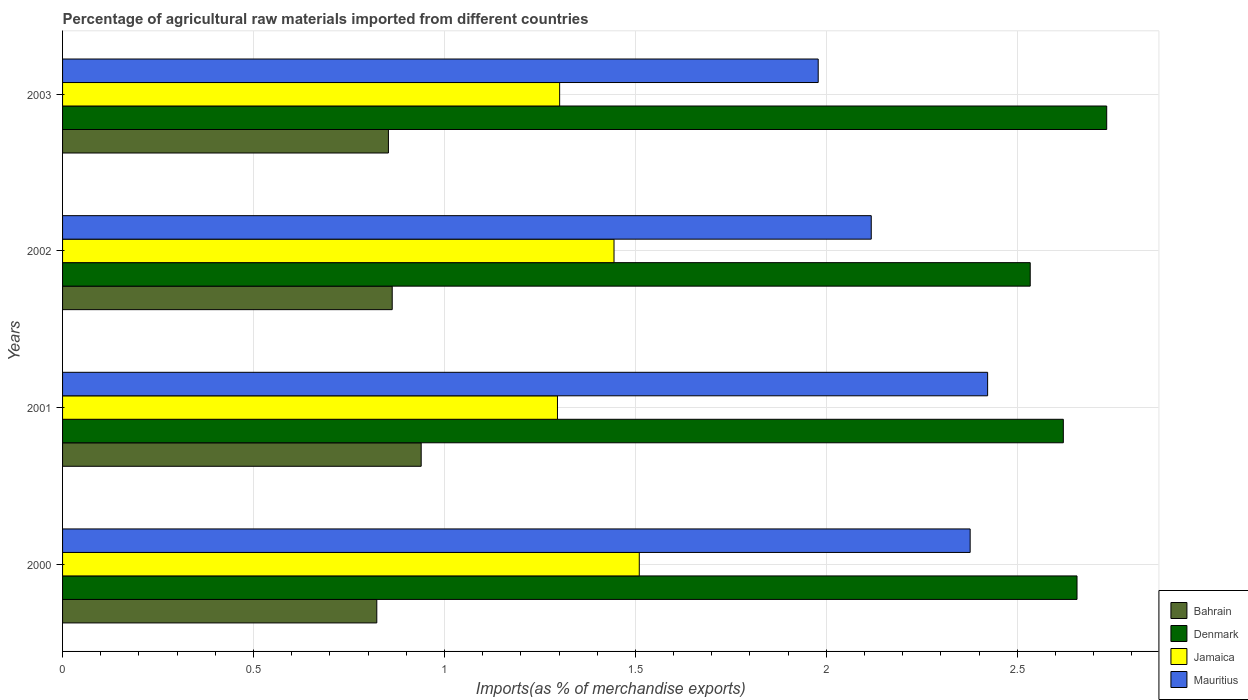How many different coloured bars are there?
Offer a terse response. 4. How many groups of bars are there?
Keep it short and to the point. 4. Are the number of bars per tick equal to the number of legend labels?
Your answer should be very brief. Yes. How many bars are there on the 2nd tick from the bottom?
Provide a succinct answer. 4. What is the label of the 2nd group of bars from the top?
Offer a very short reply. 2002. In how many cases, is the number of bars for a given year not equal to the number of legend labels?
Give a very brief answer. 0. What is the percentage of imports to different countries in Jamaica in 2002?
Keep it short and to the point. 1.44. Across all years, what is the maximum percentage of imports to different countries in Denmark?
Ensure brevity in your answer.  2.73. Across all years, what is the minimum percentage of imports to different countries in Mauritius?
Provide a short and direct response. 1.98. In which year was the percentage of imports to different countries in Denmark maximum?
Ensure brevity in your answer.  2003. What is the total percentage of imports to different countries in Denmark in the graph?
Keep it short and to the point. 10.55. What is the difference between the percentage of imports to different countries in Bahrain in 2002 and that in 2003?
Make the answer very short. 0.01. What is the difference between the percentage of imports to different countries in Jamaica in 2001 and the percentage of imports to different countries in Bahrain in 2002?
Your answer should be very brief. 0.43. What is the average percentage of imports to different countries in Mauritius per year?
Keep it short and to the point. 2.22. In the year 2002, what is the difference between the percentage of imports to different countries in Denmark and percentage of imports to different countries in Mauritius?
Your response must be concise. 0.42. What is the ratio of the percentage of imports to different countries in Jamaica in 2001 to that in 2002?
Your response must be concise. 0.9. Is the percentage of imports to different countries in Denmark in 2001 less than that in 2002?
Ensure brevity in your answer.  No. Is the difference between the percentage of imports to different countries in Denmark in 2001 and 2003 greater than the difference between the percentage of imports to different countries in Mauritius in 2001 and 2003?
Offer a very short reply. No. What is the difference between the highest and the second highest percentage of imports to different countries in Bahrain?
Offer a terse response. 0.08. What is the difference between the highest and the lowest percentage of imports to different countries in Mauritius?
Make the answer very short. 0.44. Is it the case that in every year, the sum of the percentage of imports to different countries in Mauritius and percentage of imports to different countries in Bahrain is greater than the sum of percentage of imports to different countries in Jamaica and percentage of imports to different countries in Denmark?
Provide a succinct answer. No. What does the 2nd bar from the top in 2000 represents?
Provide a short and direct response. Jamaica. What does the 3rd bar from the bottom in 2001 represents?
Provide a succinct answer. Jamaica. Is it the case that in every year, the sum of the percentage of imports to different countries in Mauritius and percentage of imports to different countries in Denmark is greater than the percentage of imports to different countries in Bahrain?
Give a very brief answer. Yes. How many bars are there?
Your answer should be very brief. 16. Are all the bars in the graph horizontal?
Make the answer very short. Yes. Are the values on the major ticks of X-axis written in scientific E-notation?
Offer a very short reply. No. Does the graph contain any zero values?
Offer a very short reply. No. What is the title of the graph?
Your answer should be compact. Percentage of agricultural raw materials imported from different countries. What is the label or title of the X-axis?
Your answer should be compact. Imports(as % of merchandise exports). What is the label or title of the Y-axis?
Offer a very short reply. Years. What is the Imports(as % of merchandise exports) in Bahrain in 2000?
Keep it short and to the point. 0.82. What is the Imports(as % of merchandise exports) in Denmark in 2000?
Keep it short and to the point. 2.66. What is the Imports(as % of merchandise exports) in Jamaica in 2000?
Your answer should be compact. 1.51. What is the Imports(as % of merchandise exports) in Mauritius in 2000?
Offer a very short reply. 2.38. What is the Imports(as % of merchandise exports) of Bahrain in 2001?
Keep it short and to the point. 0.94. What is the Imports(as % of merchandise exports) of Denmark in 2001?
Keep it short and to the point. 2.62. What is the Imports(as % of merchandise exports) in Jamaica in 2001?
Provide a short and direct response. 1.3. What is the Imports(as % of merchandise exports) in Mauritius in 2001?
Ensure brevity in your answer.  2.42. What is the Imports(as % of merchandise exports) in Bahrain in 2002?
Keep it short and to the point. 0.86. What is the Imports(as % of merchandise exports) in Denmark in 2002?
Ensure brevity in your answer.  2.53. What is the Imports(as % of merchandise exports) in Jamaica in 2002?
Provide a succinct answer. 1.44. What is the Imports(as % of merchandise exports) in Mauritius in 2002?
Your answer should be compact. 2.12. What is the Imports(as % of merchandise exports) of Bahrain in 2003?
Give a very brief answer. 0.85. What is the Imports(as % of merchandise exports) of Denmark in 2003?
Offer a terse response. 2.73. What is the Imports(as % of merchandise exports) in Jamaica in 2003?
Offer a terse response. 1.3. What is the Imports(as % of merchandise exports) of Mauritius in 2003?
Offer a terse response. 1.98. Across all years, what is the maximum Imports(as % of merchandise exports) in Bahrain?
Provide a succinct answer. 0.94. Across all years, what is the maximum Imports(as % of merchandise exports) in Denmark?
Offer a very short reply. 2.73. Across all years, what is the maximum Imports(as % of merchandise exports) in Jamaica?
Keep it short and to the point. 1.51. Across all years, what is the maximum Imports(as % of merchandise exports) in Mauritius?
Offer a terse response. 2.42. Across all years, what is the minimum Imports(as % of merchandise exports) of Bahrain?
Provide a succinct answer. 0.82. Across all years, what is the minimum Imports(as % of merchandise exports) in Denmark?
Provide a succinct answer. 2.53. Across all years, what is the minimum Imports(as % of merchandise exports) in Jamaica?
Provide a short and direct response. 1.3. Across all years, what is the minimum Imports(as % of merchandise exports) in Mauritius?
Give a very brief answer. 1.98. What is the total Imports(as % of merchandise exports) of Bahrain in the graph?
Provide a short and direct response. 3.48. What is the total Imports(as % of merchandise exports) in Denmark in the graph?
Offer a very short reply. 10.55. What is the total Imports(as % of merchandise exports) in Jamaica in the graph?
Keep it short and to the point. 5.55. What is the total Imports(as % of merchandise exports) in Mauritius in the graph?
Ensure brevity in your answer.  8.9. What is the difference between the Imports(as % of merchandise exports) of Bahrain in 2000 and that in 2001?
Give a very brief answer. -0.12. What is the difference between the Imports(as % of merchandise exports) in Denmark in 2000 and that in 2001?
Your response must be concise. 0.04. What is the difference between the Imports(as % of merchandise exports) in Jamaica in 2000 and that in 2001?
Your response must be concise. 0.21. What is the difference between the Imports(as % of merchandise exports) of Mauritius in 2000 and that in 2001?
Ensure brevity in your answer.  -0.05. What is the difference between the Imports(as % of merchandise exports) of Bahrain in 2000 and that in 2002?
Provide a short and direct response. -0.04. What is the difference between the Imports(as % of merchandise exports) in Denmark in 2000 and that in 2002?
Offer a very short reply. 0.12. What is the difference between the Imports(as % of merchandise exports) in Jamaica in 2000 and that in 2002?
Make the answer very short. 0.07. What is the difference between the Imports(as % of merchandise exports) in Mauritius in 2000 and that in 2002?
Your response must be concise. 0.26. What is the difference between the Imports(as % of merchandise exports) of Bahrain in 2000 and that in 2003?
Your answer should be very brief. -0.03. What is the difference between the Imports(as % of merchandise exports) of Denmark in 2000 and that in 2003?
Provide a succinct answer. -0.08. What is the difference between the Imports(as % of merchandise exports) in Jamaica in 2000 and that in 2003?
Give a very brief answer. 0.21. What is the difference between the Imports(as % of merchandise exports) in Mauritius in 2000 and that in 2003?
Give a very brief answer. 0.4. What is the difference between the Imports(as % of merchandise exports) in Bahrain in 2001 and that in 2002?
Make the answer very short. 0.08. What is the difference between the Imports(as % of merchandise exports) of Denmark in 2001 and that in 2002?
Your answer should be compact. 0.09. What is the difference between the Imports(as % of merchandise exports) in Jamaica in 2001 and that in 2002?
Provide a succinct answer. -0.15. What is the difference between the Imports(as % of merchandise exports) of Mauritius in 2001 and that in 2002?
Your answer should be compact. 0.3. What is the difference between the Imports(as % of merchandise exports) in Bahrain in 2001 and that in 2003?
Your answer should be compact. 0.09. What is the difference between the Imports(as % of merchandise exports) of Denmark in 2001 and that in 2003?
Your response must be concise. -0.11. What is the difference between the Imports(as % of merchandise exports) of Jamaica in 2001 and that in 2003?
Provide a short and direct response. -0.01. What is the difference between the Imports(as % of merchandise exports) in Mauritius in 2001 and that in 2003?
Your answer should be very brief. 0.44. What is the difference between the Imports(as % of merchandise exports) in Bahrain in 2002 and that in 2003?
Your answer should be compact. 0.01. What is the difference between the Imports(as % of merchandise exports) of Denmark in 2002 and that in 2003?
Provide a succinct answer. -0.2. What is the difference between the Imports(as % of merchandise exports) in Jamaica in 2002 and that in 2003?
Offer a very short reply. 0.14. What is the difference between the Imports(as % of merchandise exports) in Mauritius in 2002 and that in 2003?
Offer a very short reply. 0.14. What is the difference between the Imports(as % of merchandise exports) in Bahrain in 2000 and the Imports(as % of merchandise exports) in Denmark in 2001?
Your answer should be compact. -1.8. What is the difference between the Imports(as % of merchandise exports) in Bahrain in 2000 and the Imports(as % of merchandise exports) in Jamaica in 2001?
Your answer should be very brief. -0.47. What is the difference between the Imports(as % of merchandise exports) in Bahrain in 2000 and the Imports(as % of merchandise exports) in Mauritius in 2001?
Your answer should be compact. -1.6. What is the difference between the Imports(as % of merchandise exports) in Denmark in 2000 and the Imports(as % of merchandise exports) in Jamaica in 2001?
Provide a short and direct response. 1.36. What is the difference between the Imports(as % of merchandise exports) in Denmark in 2000 and the Imports(as % of merchandise exports) in Mauritius in 2001?
Ensure brevity in your answer.  0.23. What is the difference between the Imports(as % of merchandise exports) of Jamaica in 2000 and the Imports(as % of merchandise exports) of Mauritius in 2001?
Your answer should be compact. -0.91. What is the difference between the Imports(as % of merchandise exports) of Bahrain in 2000 and the Imports(as % of merchandise exports) of Denmark in 2002?
Keep it short and to the point. -1.71. What is the difference between the Imports(as % of merchandise exports) of Bahrain in 2000 and the Imports(as % of merchandise exports) of Jamaica in 2002?
Your answer should be very brief. -0.62. What is the difference between the Imports(as % of merchandise exports) of Bahrain in 2000 and the Imports(as % of merchandise exports) of Mauritius in 2002?
Your answer should be very brief. -1.29. What is the difference between the Imports(as % of merchandise exports) of Denmark in 2000 and the Imports(as % of merchandise exports) of Jamaica in 2002?
Offer a terse response. 1.21. What is the difference between the Imports(as % of merchandise exports) in Denmark in 2000 and the Imports(as % of merchandise exports) in Mauritius in 2002?
Make the answer very short. 0.54. What is the difference between the Imports(as % of merchandise exports) of Jamaica in 2000 and the Imports(as % of merchandise exports) of Mauritius in 2002?
Offer a very short reply. -0.61. What is the difference between the Imports(as % of merchandise exports) in Bahrain in 2000 and the Imports(as % of merchandise exports) in Denmark in 2003?
Your answer should be very brief. -1.91. What is the difference between the Imports(as % of merchandise exports) in Bahrain in 2000 and the Imports(as % of merchandise exports) in Jamaica in 2003?
Ensure brevity in your answer.  -0.48. What is the difference between the Imports(as % of merchandise exports) of Bahrain in 2000 and the Imports(as % of merchandise exports) of Mauritius in 2003?
Offer a very short reply. -1.16. What is the difference between the Imports(as % of merchandise exports) in Denmark in 2000 and the Imports(as % of merchandise exports) in Jamaica in 2003?
Offer a terse response. 1.35. What is the difference between the Imports(as % of merchandise exports) in Denmark in 2000 and the Imports(as % of merchandise exports) in Mauritius in 2003?
Keep it short and to the point. 0.68. What is the difference between the Imports(as % of merchandise exports) in Jamaica in 2000 and the Imports(as % of merchandise exports) in Mauritius in 2003?
Provide a short and direct response. -0.47. What is the difference between the Imports(as % of merchandise exports) in Bahrain in 2001 and the Imports(as % of merchandise exports) in Denmark in 2002?
Make the answer very short. -1.59. What is the difference between the Imports(as % of merchandise exports) in Bahrain in 2001 and the Imports(as % of merchandise exports) in Jamaica in 2002?
Your response must be concise. -0.51. What is the difference between the Imports(as % of merchandise exports) in Bahrain in 2001 and the Imports(as % of merchandise exports) in Mauritius in 2002?
Offer a terse response. -1.18. What is the difference between the Imports(as % of merchandise exports) of Denmark in 2001 and the Imports(as % of merchandise exports) of Jamaica in 2002?
Ensure brevity in your answer.  1.18. What is the difference between the Imports(as % of merchandise exports) in Denmark in 2001 and the Imports(as % of merchandise exports) in Mauritius in 2002?
Keep it short and to the point. 0.5. What is the difference between the Imports(as % of merchandise exports) of Jamaica in 2001 and the Imports(as % of merchandise exports) of Mauritius in 2002?
Provide a succinct answer. -0.82. What is the difference between the Imports(as % of merchandise exports) in Bahrain in 2001 and the Imports(as % of merchandise exports) in Denmark in 2003?
Keep it short and to the point. -1.8. What is the difference between the Imports(as % of merchandise exports) of Bahrain in 2001 and the Imports(as % of merchandise exports) of Jamaica in 2003?
Your answer should be very brief. -0.36. What is the difference between the Imports(as % of merchandise exports) in Bahrain in 2001 and the Imports(as % of merchandise exports) in Mauritius in 2003?
Provide a succinct answer. -1.04. What is the difference between the Imports(as % of merchandise exports) in Denmark in 2001 and the Imports(as % of merchandise exports) in Jamaica in 2003?
Offer a very short reply. 1.32. What is the difference between the Imports(as % of merchandise exports) in Denmark in 2001 and the Imports(as % of merchandise exports) in Mauritius in 2003?
Your answer should be very brief. 0.64. What is the difference between the Imports(as % of merchandise exports) of Jamaica in 2001 and the Imports(as % of merchandise exports) of Mauritius in 2003?
Offer a very short reply. -0.68. What is the difference between the Imports(as % of merchandise exports) of Bahrain in 2002 and the Imports(as % of merchandise exports) of Denmark in 2003?
Offer a very short reply. -1.87. What is the difference between the Imports(as % of merchandise exports) in Bahrain in 2002 and the Imports(as % of merchandise exports) in Jamaica in 2003?
Your answer should be compact. -0.44. What is the difference between the Imports(as % of merchandise exports) of Bahrain in 2002 and the Imports(as % of merchandise exports) of Mauritius in 2003?
Provide a succinct answer. -1.12. What is the difference between the Imports(as % of merchandise exports) in Denmark in 2002 and the Imports(as % of merchandise exports) in Jamaica in 2003?
Provide a succinct answer. 1.23. What is the difference between the Imports(as % of merchandise exports) in Denmark in 2002 and the Imports(as % of merchandise exports) in Mauritius in 2003?
Offer a very short reply. 0.56. What is the difference between the Imports(as % of merchandise exports) in Jamaica in 2002 and the Imports(as % of merchandise exports) in Mauritius in 2003?
Provide a succinct answer. -0.53. What is the average Imports(as % of merchandise exports) of Bahrain per year?
Your response must be concise. 0.87. What is the average Imports(as % of merchandise exports) in Denmark per year?
Provide a short and direct response. 2.64. What is the average Imports(as % of merchandise exports) in Jamaica per year?
Offer a terse response. 1.39. What is the average Imports(as % of merchandise exports) in Mauritius per year?
Ensure brevity in your answer.  2.22. In the year 2000, what is the difference between the Imports(as % of merchandise exports) in Bahrain and Imports(as % of merchandise exports) in Denmark?
Your answer should be compact. -1.83. In the year 2000, what is the difference between the Imports(as % of merchandise exports) of Bahrain and Imports(as % of merchandise exports) of Jamaica?
Offer a terse response. -0.69. In the year 2000, what is the difference between the Imports(as % of merchandise exports) of Bahrain and Imports(as % of merchandise exports) of Mauritius?
Offer a very short reply. -1.55. In the year 2000, what is the difference between the Imports(as % of merchandise exports) in Denmark and Imports(as % of merchandise exports) in Jamaica?
Make the answer very short. 1.15. In the year 2000, what is the difference between the Imports(as % of merchandise exports) in Denmark and Imports(as % of merchandise exports) in Mauritius?
Your answer should be compact. 0.28. In the year 2000, what is the difference between the Imports(as % of merchandise exports) in Jamaica and Imports(as % of merchandise exports) in Mauritius?
Make the answer very short. -0.87. In the year 2001, what is the difference between the Imports(as % of merchandise exports) of Bahrain and Imports(as % of merchandise exports) of Denmark?
Your answer should be compact. -1.68. In the year 2001, what is the difference between the Imports(as % of merchandise exports) of Bahrain and Imports(as % of merchandise exports) of Jamaica?
Offer a terse response. -0.36. In the year 2001, what is the difference between the Imports(as % of merchandise exports) in Bahrain and Imports(as % of merchandise exports) in Mauritius?
Your answer should be compact. -1.48. In the year 2001, what is the difference between the Imports(as % of merchandise exports) of Denmark and Imports(as % of merchandise exports) of Jamaica?
Ensure brevity in your answer.  1.32. In the year 2001, what is the difference between the Imports(as % of merchandise exports) of Denmark and Imports(as % of merchandise exports) of Mauritius?
Provide a succinct answer. 0.2. In the year 2001, what is the difference between the Imports(as % of merchandise exports) in Jamaica and Imports(as % of merchandise exports) in Mauritius?
Give a very brief answer. -1.13. In the year 2002, what is the difference between the Imports(as % of merchandise exports) of Bahrain and Imports(as % of merchandise exports) of Denmark?
Provide a short and direct response. -1.67. In the year 2002, what is the difference between the Imports(as % of merchandise exports) of Bahrain and Imports(as % of merchandise exports) of Jamaica?
Offer a terse response. -0.58. In the year 2002, what is the difference between the Imports(as % of merchandise exports) in Bahrain and Imports(as % of merchandise exports) in Mauritius?
Ensure brevity in your answer.  -1.25. In the year 2002, what is the difference between the Imports(as % of merchandise exports) of Denmark and Imports(as % of merchandise exports) of Jamaica?
Offer a terse response. 1.09. In the year 2002, what is the difference between the Imports(as % of merchandise exports) of Denmark and Imports(as % of merchandise exports) of Mauritius?
Your answer should be very brief. 0.42. In the year 2002, what is the difference between the Imports(as % of merchandise exports) in Jamaica and Imports(as % of merchandise exports) in Mauritius?
Ensure brevity in your answer.  -0.67. In the year 2003, what is the difference between the Imports(as % of merchandise exports) in Bahrain and Imports(as % of merchandise exports) in Denmark?
Provide a short and direct response. -1.88. In the year 2003, what is the difference between the Imports(as % of merchandise exports) of Bahrain and Imports(as % of merchandise exports) of Jamaica?
Offer a very short reply. -0.45. In the year 2003, what is the difference between the Imports(as % of merchandise exports) of Bahrain and Imports(as % of merchandise exports) of Mauritius?
Keep it short and to the point. -1.13. In the year 2003, what is the difference between the Imports(as % of merchandise exports) of Denmark and Imports(as % of merchandise exports) of Jamaica?
Keep it short and to the point. 1.43. In the year 2003, what is the difference between the Imports(as % of merchandise exports) of Denmark and Imports(as % of merchandise exports) of Mauritius?
Your answer should be very brief. 0.76. In the year 2003, what is the difference between the Imports(as % of merchandise exports) of Jamaica and Imports(as % of merchandise exports) of Mauritius?
Your response must be concise. -0.68. What is the ratio of the Imports(as % of merchandise exports) of Bahrain in 2000 to that in 2001?
Give a very brief answer. 0.88. What is the ratio of the Imports(as % of merchandise exports) in Denmark in 2000 to that in 2001?
Provide a succinct answer. 1.01. What is the ratio of the Imports(as % of merchandise exports) of Jamaica in 2000 to that in 2001?
Your answer should be very brief. 1.17. What is the ratio of the Imports(as % of merchandise exports) in Mauritius in 2000 to that in 2001?
Give a very brief answer. 0.98. What is the ratio of the Imports(as % of merchandise exports) of Bahrain in 2000 to that in 2002?
Ensure brevity in your answer.  0.95. What is the ratio of the Imports(as % of merchandise exports) in Denmark in 2000 to that in 2002?
Offer a terse response. 1.05. What is the ratio of the Imports(as % of merchandise exports) of Jamaica in 2000 to that in 2002?
Offer a very short reply. 1.05. What is the ratio of the Imports(as % of merchandise exports) of Mauritius in 2000 to that in 2002?
Provide a succinct answer. 1.12. What is the ratio of the Imports(as % of merchandise exports) in Bahrain in 2000 to that in 2003?
Your answer should be compact. 0.96. What is the ratio of the Imports(as % of merchandise exports) in Denmark in 2000 to that in 2003?
Provide a short and direct response. 0.97. What is the ratio of the Imports(as % of merchandise exports) of Jamaica in 2000 to that in 2003?
Offer a terse response. 1.16. What is the ratio of the Imports(as % of merchandise exports) in Mauritius in 2000 to that in 2003?
Offer a terse response. 1.2. What is the ratio of the Imports(as % of merchandise exports) of Bahrain in 2001 to that in 2002?
Give a very brief answer. 1.09. What is the ratio of the Imports(as % of merchandise exports) in Denmark in 2001 to that in 2002?
Give a very brief answer. 1.03. What is the ratio of the Imports(as % of merchandise exports) in Jamaica in 2001 to that in 2002?
Your answer should be very brief. 0.9. What is the ratio of the Imports(as % of merchandise exports) in Mauritius in 2001 to that in 2002?
Offer a terse response. 1.14. What is the ratio of the Imports(as % of merchandise exports) in Bahrain in 2001 to that in 2003?
Offer a terse response. 1.1. What is the ratio of the Imports(as % of merchandise exports) of Denmark in 2001 to that in 2003?
Ensure brevity in your answer.  0.96. What is the ratio of the Imports(as % of merchandise exports) in Mauritius in 2001 to that in 2003?
Make the answer very short. 1.22. What is the ratio of the Imports(as % of merchandise exports) in Bahrain in 2002 to that in 2003?
Ensure brevity in your answer.  1.01. What is the ratio of the Imports(as % of merchandise exports) of Denmark in 2002 to that in 2003?
Provide a short and direct response. 0.93. What is the ratio of the Imports(as % of merchandise exports) of Jamaica in 2002 to that in 2003?
Offer a terse response. 1.11. What is the ratio of the Imports(as % of merchandise exports) in Mauritius in 2002 to that in 2003?
Your answer should be very brief. 1.07. What is the difference between the highest and the second highest Imports(as % of merchandise exports) of Bahrain?
Your answer should be compact. 0.08. What is the difference between the highest and the second highest Imports(as % of merchandise exports) in Denmark?
Offer a very short reply. 0.08. What is the difference between the highest and the second highest Imports(as % of merchandise exports) of Jamaica?
Give a very brief answer. 0.07. What is the difference between the highest and the second highest Imports(as % of merchandise exports) of Mauritius?
Keep it short and to the point. 0.05. What is the difference between the highest and the lowest Imports(as % of merchandise exports) in Bahrain?
Give a very brief answer. 0.12. What is the difference between the highest and the lowest Imports(as % of merchandise exports) in Denmark?
Provide a succinct answer. 0.2. What is the difference between the highest and the lowest Imports(as % of merchandise exports) of Jamaica?
Your response must be concise. 0.21. What is the difference between the highest and the lowest Imports(as % of merchandise exports) in Mauritius?
Keep it short and to the point. 0.44. 